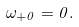Convert formula to latex. <formula><loc_0><loc_0><loc_500><loc_500>\omega _ { + 0 } = 0 .</formula> 